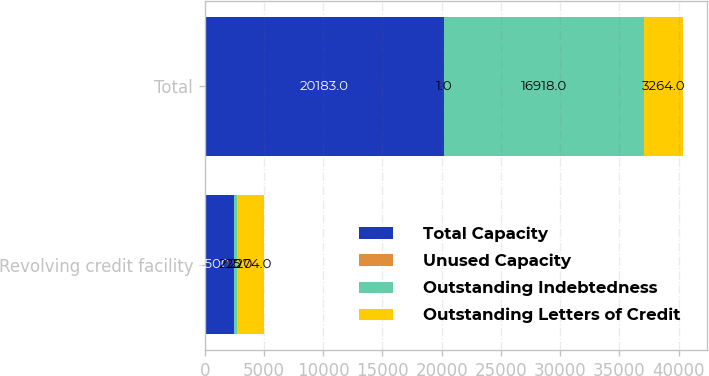Convert chart to OTSL. <chart><loc_0><loc_0><loc_500><loc_500><stacked_bar_chart><ecel><fcel>Revolving credit facility<fcel>Total<nl><fcel>Total Capacity<fcel>2500<fcel>20183<nl><fcel>Unused Capacity<fcel>1<fcel>1<nl><fcel>Outstanding Indebtedness<fcel>225<fcel>16918<nl><fcel>Outstanding Letters of Credit<fcel>2274<fcel>3264<nl></chart> 